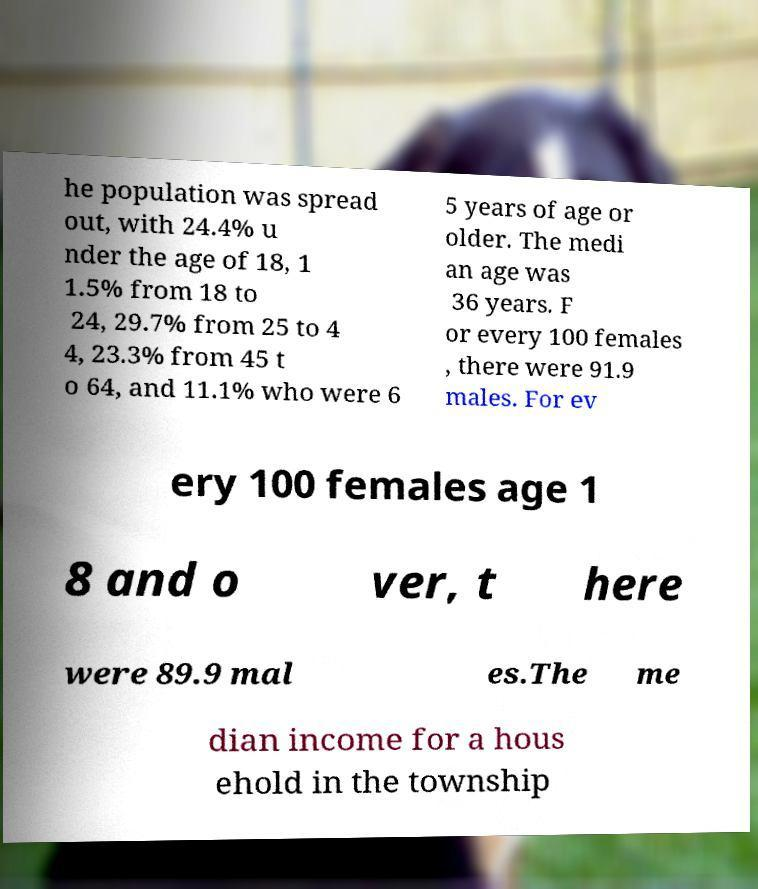What messages or text are displayed in this image? I need them in a readable, typed format. he population was spread out, with 24.4% u nder the age of 18, 1 1.5% from 18 to 24, 29.7% from 25 to 4 4, 23.3% from 45 t o 64, and 11.1% who were 6 5 years of age or older. The medi an age was 36 years. F or every 100 females , there were 91.9 males. For ev ery 100 females age 1 8 and o ver, t here were 89.9 mal es.The me dian income for a hous ehold in the township 